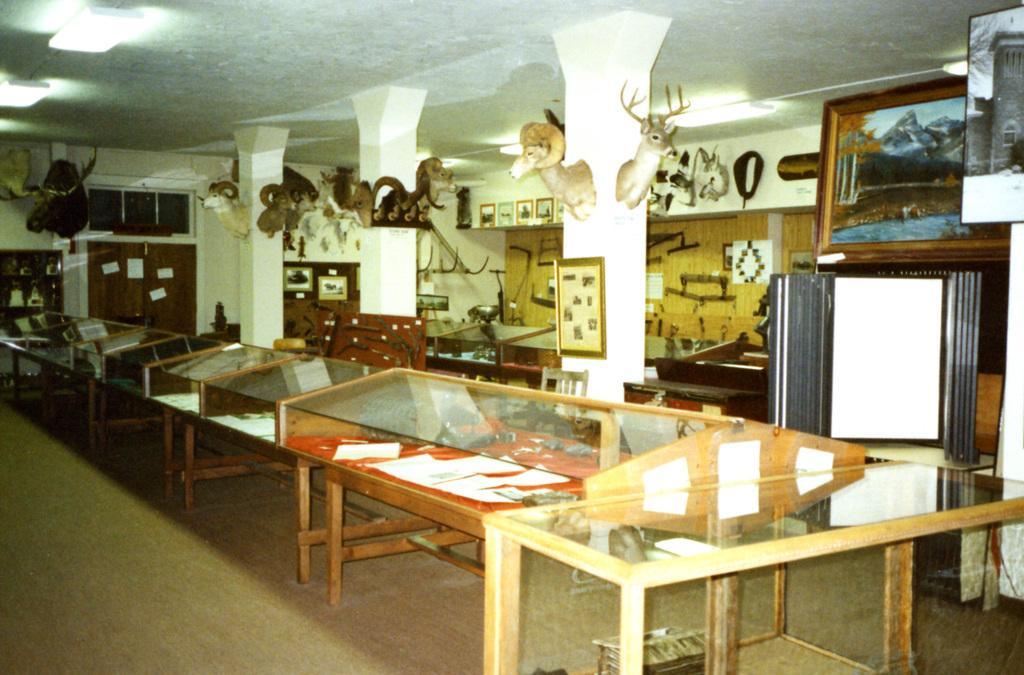How would you summarize this image in a sentence or two? In this image we can see many tables, photo frames on wall and statues on pillars. 